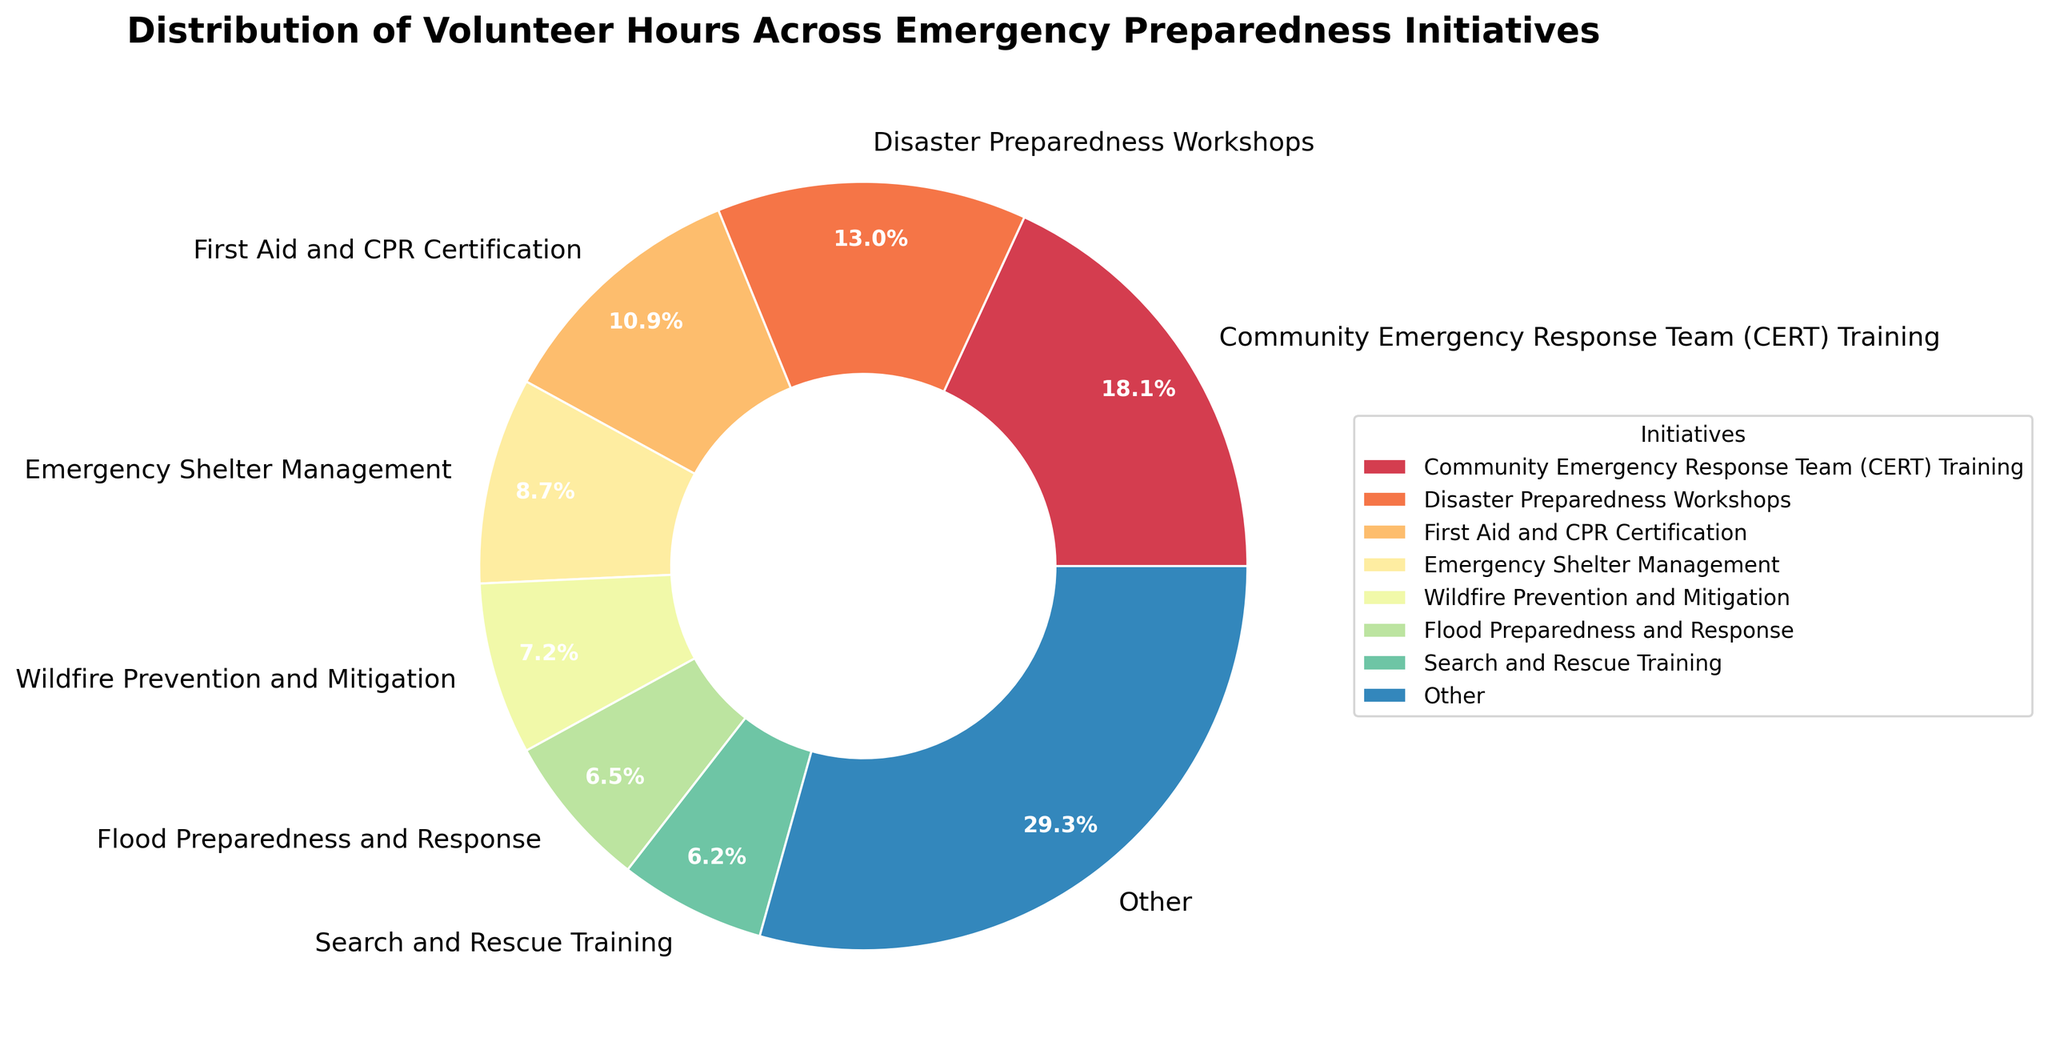What proportion of volunteer hours were dedicated to the Community Emergency Response Team (CERT) Training? The figure shows pie wedges with corresponding percentages, identifying 'Community Emergency Response Team (CERT) Training' as 19.9% of the total volunteer hours.
Answer: 19.9% Which initiative received fewer volunteer hours, Flood Preparedness and Response or Search and Rescue Training? By comparing the percentage labels in the pie chart, it's evident that 'Flood Preparedness and Response' is 6.7%, and 'Search and Rescue Training' is 6.3%. Therefore, 'Search and Rescue Training' received fewer hours.
Answer: Search and Rescue Training What percentage of volunteer hours were dedicated to the top two initiatives? By identifying the top two wedges in the pie chart, with percentages 19.9% (CERT Training) and 14.3% (Disaster Preparedness Workshops), summing these gives 19.9% + 14.3% = 34.2%.
Answer: 34.2% Which initiatives fall under the 'Other' category, and what is the total percentage for them? 'Other' groups initiatives beyond the top 7. The figure combines the percentages of initiatives beyond the seventh rank. The percentage for 'Other' is visually identified in the chart. Summing up the relevant small wedges provides the 'Other' percentage.
Answer: These include Emergency Communications, Earthquake Readiness Programs, Severe Weather Preparedness, Mass Casualty Incident Training, Pet Emergency Preparedness, Senior Citizen Emergency Planning, Youth Emergency Preparedness Education. The total percentage is around 15.4% Which visual segment indicates the smallest proportion of volunteer hours, and what is its percentage? By visually inspecting the smallest wedge in the pie chart, which is 'Youth Emergency Preparedness Education,' and its percentage label shows 2.4%.
Answer: Youth Emergency Preparedness Education, 2.4% 